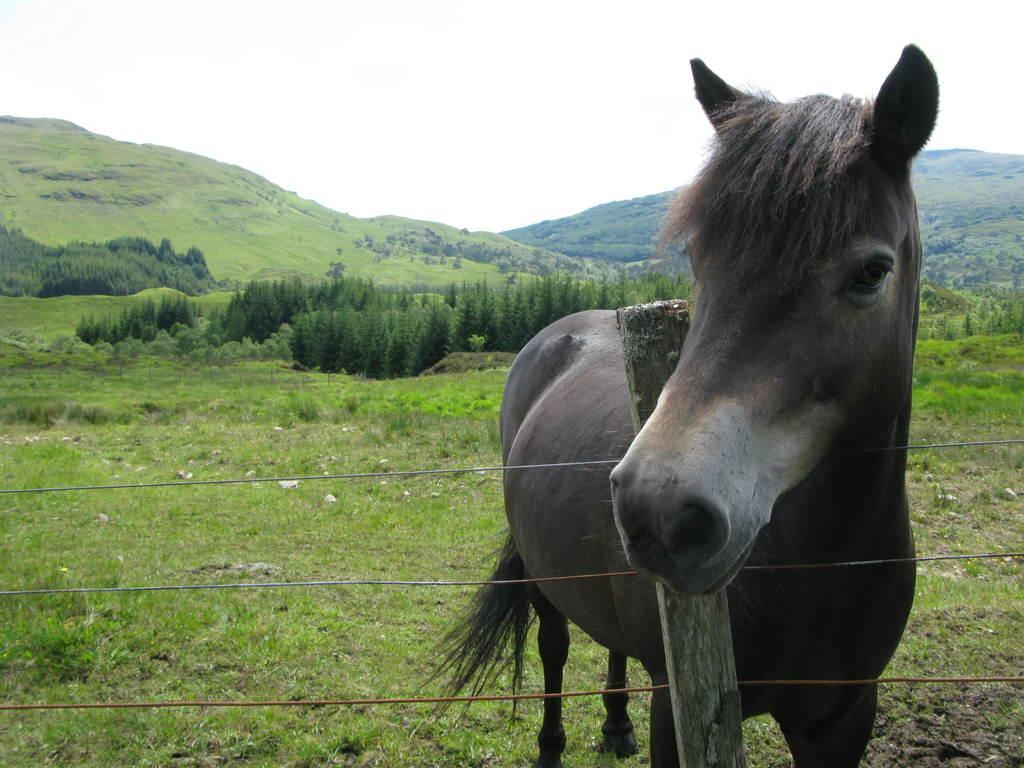How would you summarize this image in a sentence or two? In this image I can see a horse standing in front of a fencing. I can see trees, open garden and mountains behind the horse. At the top of the image I can see the sky.  